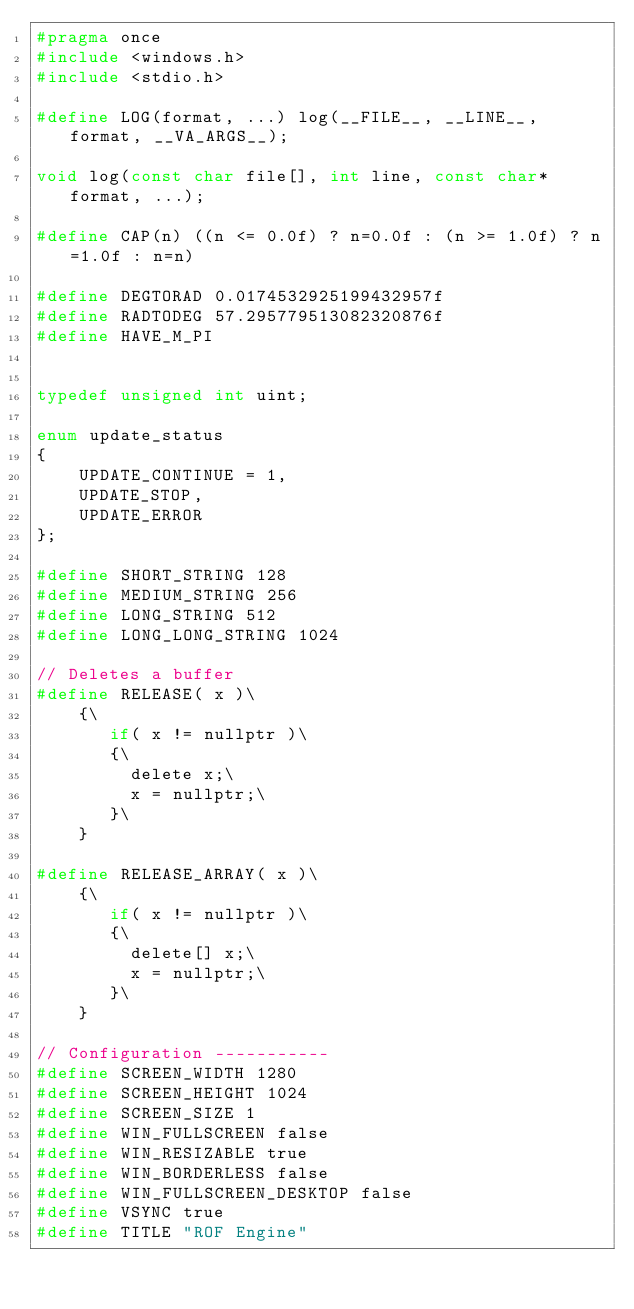<code> <loc_0><loc_0><loc_500><loc_500><_C_>#pragma once
#include <windows.h>
#include <stdio.h>

#define LOG(format, ...) log(__FILE__, __LINE__, format, __VA_ARGS__);

void log(const char file[], int line, const char* format, ...);

#define CAP(n) ((n <= 0.0f) ? n=0.0f : (n >= 1.0f) ? n=1.0f : n=n)

#define DEGTORAD 0.0174532925199432957f
#define RADTODEG 57.295779513082320876f
#define HAVE_M_PI


typedef unsigned int uint;

enum update_status
{
	UPDATE_CONTINUE = 1,
	UPDATE_STOP,
	UPDATE_ERROR
};

#define SHORT_STRING 128
#define MEDIUM_STRING 256
#define LONG_STRING 512
#define LONG_LONG_STRING 1024

// Deletes a buffer
#define RELEASE( x )\
    {\
       if( x != nullptr )\
       {\
         delete x;\
	     x = nullptr;\
       }\
    }

#define RELEASE_ARRAY( x )\
    {\
       if( x != nullptr )\
       {\
         delete[] x;\
	     x = nullptr;\
       }\
    }

// Configuration -----------
#define SCREEN_WIDTH 1280
#define SCREEN_HEIGHT 1024
#define SCREEN_SIZE 1
#define WIN_FULLSCREEN false
#define WIN_RESIZABLE true
#define WIN_BORDERLESS false
#define WIN_FULLSCREEN_DESKTOP false
#define VSYNC true
#define TITLE "ROF Engine"</code> 